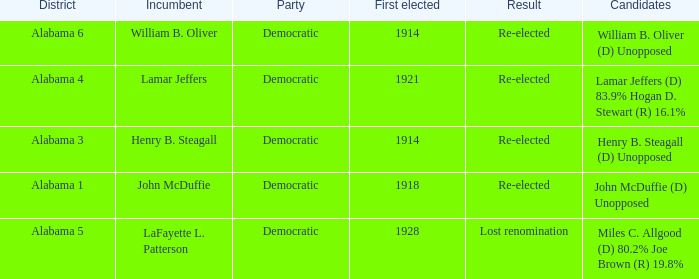How many in lost renomination results were elected first? 1928.0. 